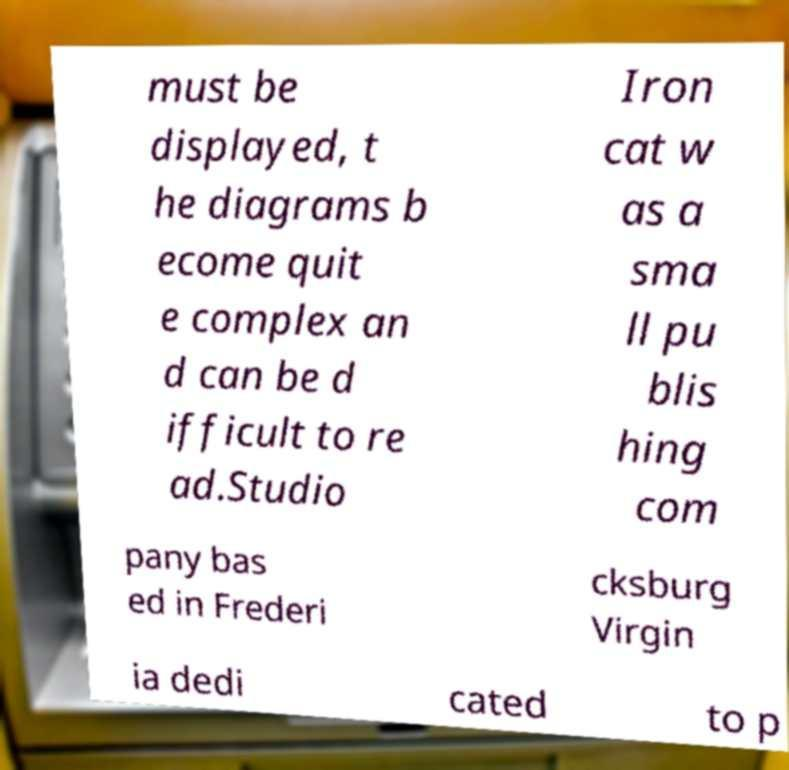Please identify and transcribe the text found in this image. must be displayed, t he diagrams b ecome quit e complex an d can be d ifficult to re ad.Studio Iron cat w as a sma ll pu blis hing com pany bas ed in Frederi cksburg Virgin ia dedi cated to p 